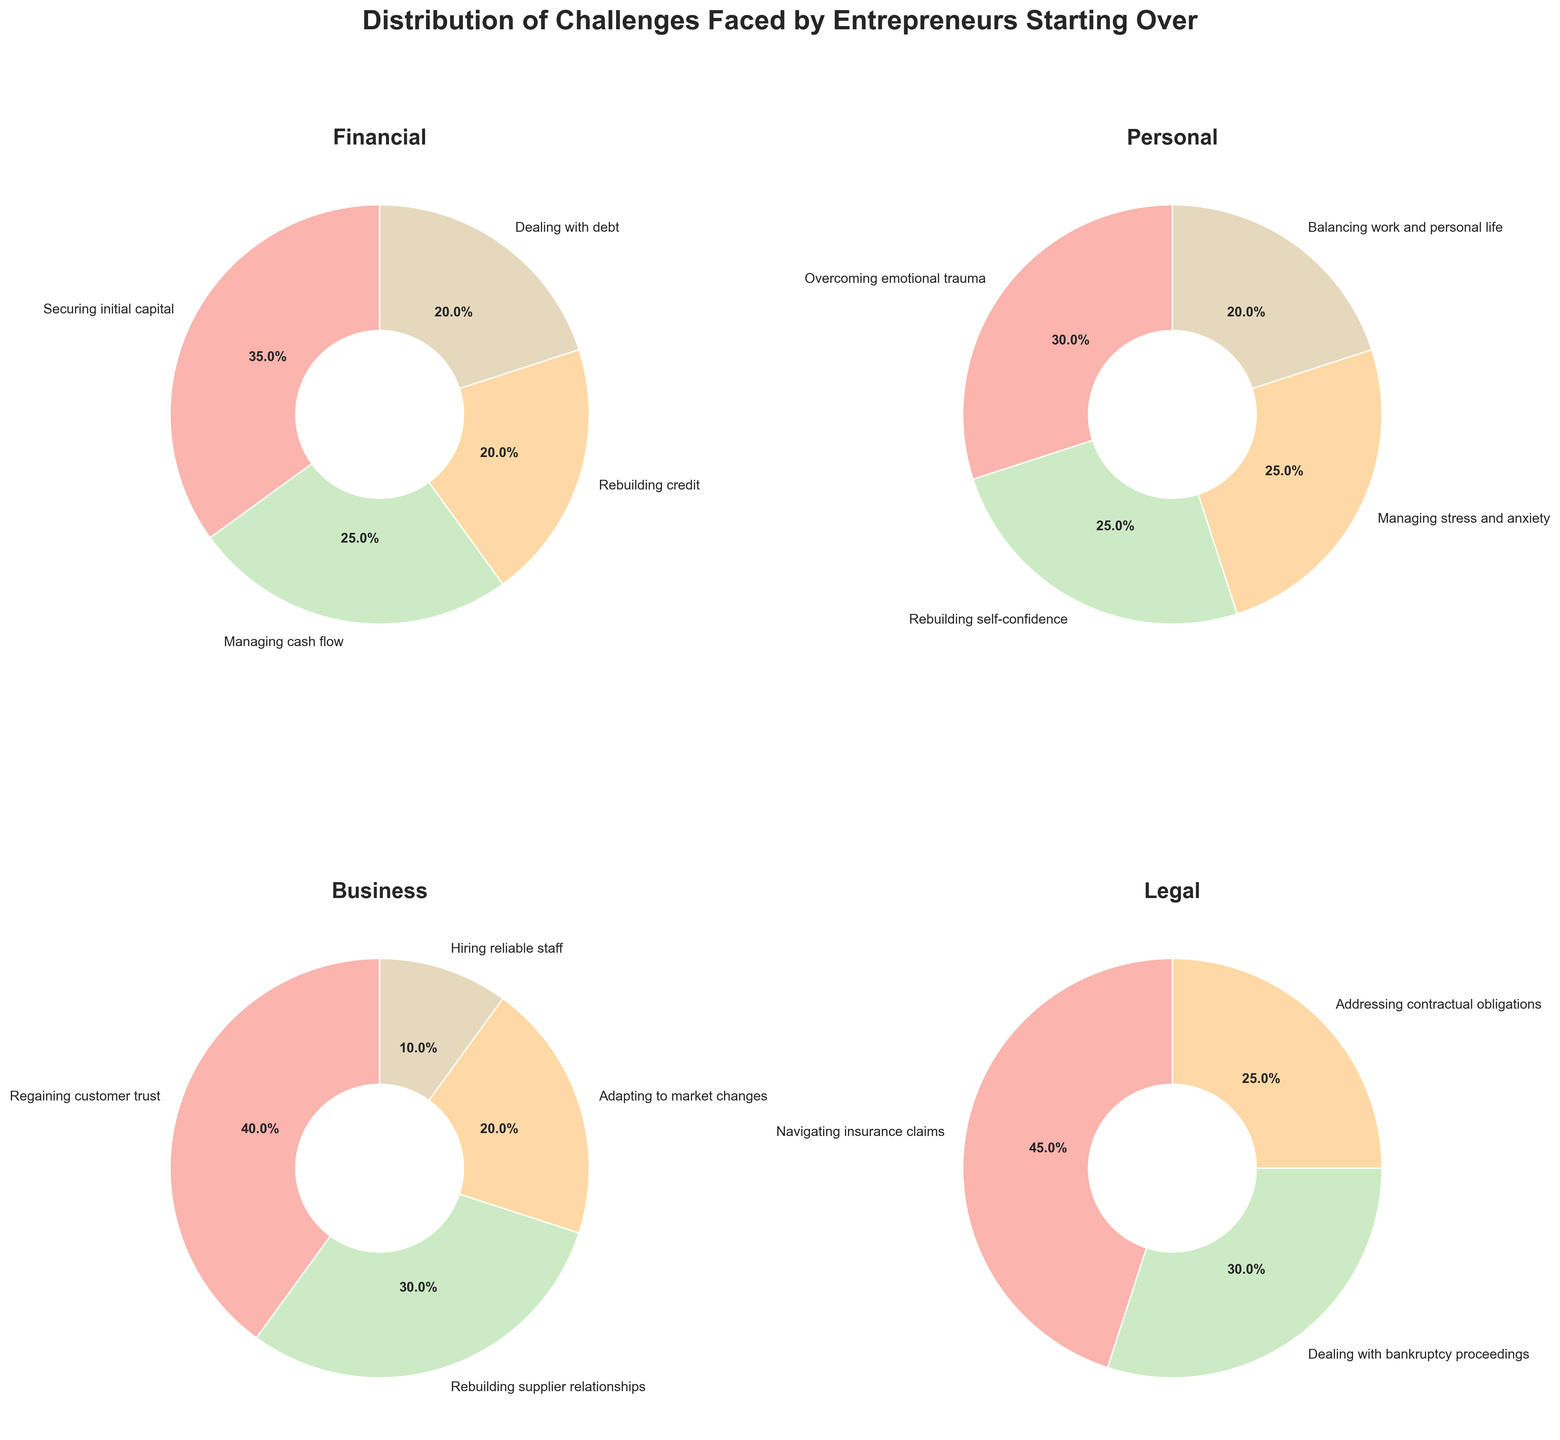Which category has the highest percentage for a single challenge? By reviewing the pie charts, the "Legal" category shows "Navigating insurance claims" with 45%, which is higher than any single challenge in the other categories.
Answer: Legal What percentage of challenges in the Personal category is allocated to overcoming emotional trauma? In the Personal pie chart, "Overcoming emotional trauma" is labeled with 30%.
Answer: 30% How do the percentages of managing stress and anxiety compare to balancing work and personal life within the Personal category? In the Personal category, managing stress and anxiety is 25%, and balancing work and personal life is 20%. Comparatively, managing stress and anxiety is 5% higher than balancing work and personal life.
Answer: 5% Which challenge in the Business category is associated with 40% of the total distribution? The Business category pie chart shows "Regaining customer trust" with 40%.
Answer: Regaining customer trust When combining the percentages of managing cash flow and securing initial capital in the Financial category, what is the total? The Financial pie chart shows managing cash flow as 25% and securing initial capital as 35%. Added together, 25% + 35% equals 60%.
Answer: 60% What is the difference between the highest and lowest percentage challenges in the Legal category? The Legal pie chart reveals the highest percentage challenge is "Navigating insurance claims" at 45%, and the lowest is "Addressing contractual obligations" at 25%. The difference is 45% - 25% = 20%.
Answer: 20% Which category has the least distribution for a single challenge, and what is that percentage? Scanning through the pie charts, the Business category has hiring reliable staff with 10%, which is the smallest single challenge percentage among all categories.
Answer: Business, 10% How does the percentage of dealing with debt compare to that of rebuilding credit in the Financial category? Both dealing with debt and rebuilding credit are marked at 20% in the Financial pie chart, indicating they are equal.
Answer: Equal What's the combined percentage for challenges related to rebuilding in the Financial category? In the Financial category, rebuilding-related challenges are rebuilding credit (20%) and dealing with debt (20%). Combined, they make up 20% + 20% = 40%.
Answer: 40% If you sum up the two smallest percentages across all categories, what is the total? The two smallest percentages are hiring reliable staff in Business (10%) and balancing work and personal life in Personal (20%). Their sum is 10% + 20% = 30%.
Answer: 30% 